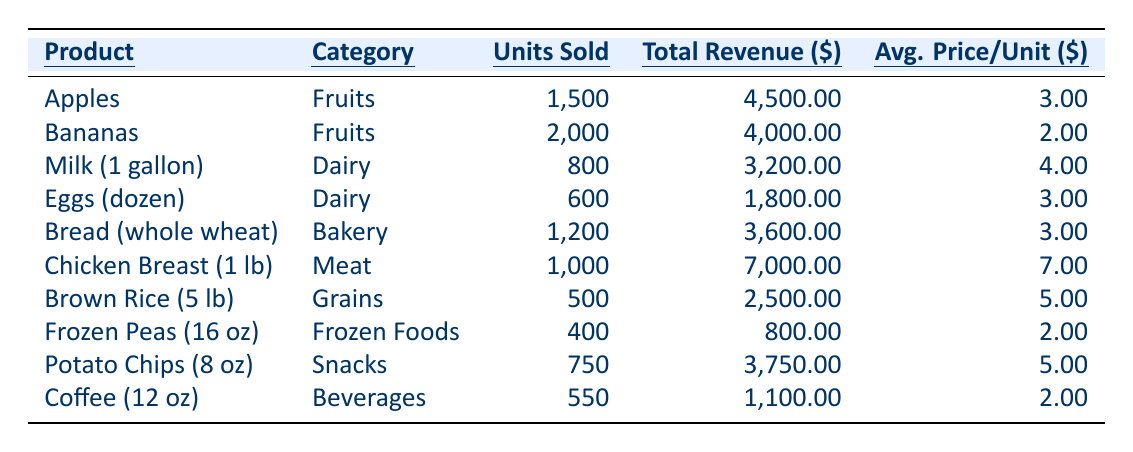What is the total revenue generated from selling Apples? From the table, the total revenue for Apples is listed as 4,500.00.
Answer: 4,500.00 How many units of Bananas were sold? The table indicates that 2,000 units of Bananas were sold.
Answer: 2,000 What is the average price per unit for Chicken Breast? According to the table, the average price per unit for Chicken Breast is 7.00.
Answer: 7.00 What is the total revenue generated from the Dairy category? The total revenue from Dairy includes Milk at 3,200.00 and Eggs at 1,800.00. Summing these gives 3,200.00 + 1,800.00 = 5,000.00.
Answer: 5,000.00 Which product sold the highest number of units? By comparing the units sold across products in the table, Bananas at 2,000 units is the highest.
Answer: Bananas Are more units of Coffee sold than Frozen Peas? Coffee has 550 units sold while Frozen Peas has 400. Since 550 is greater than 400, the statement is true.
Answer: Yes What is the total number of units sold across all products? By summing all units sold: 1,500 + 2,000 + 800 + 600 + 1,200 + 1,000 + 500 + 400 + 750 + 550 = 9,300 total units.
Answer: 9,300 Which category had the lowest total revenue generated? Calculating total revenue by category, Frozen Foods had 800.00, which is the lowest when compared to others.
Answer: Frozen Foods What percentage of total revenue did Chicken Breast contribute? Total revenue from all products is 30,700.00. Chicken Breast's revenue of 7,000.00 contributes (7,000.00 / 30,700.00) * 100 ≈ 22.8%.
Answer: 22.8% What is the difference in total revenue between the highest and lowest selling products? The highest total revenue is from Chicken Breast at 7,000.00, and the lowest is from Frozen Peas at 800.00. The difference is 7,000.00 - 800.00 = 6,200.00.
Answer: 6,200.00 